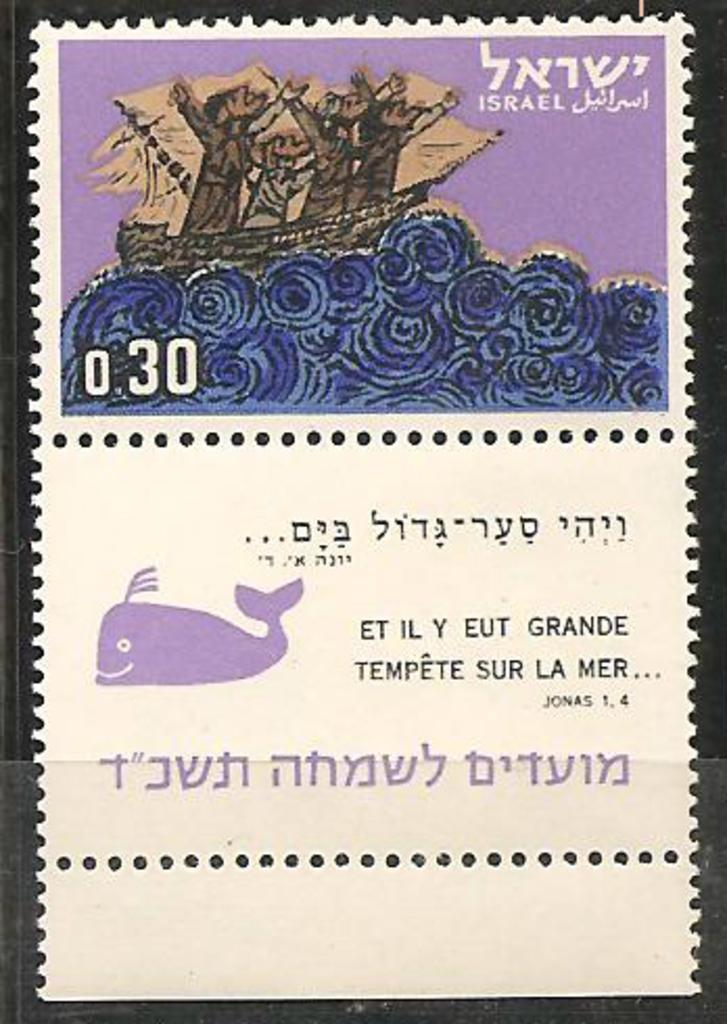What is the main subject in the image? There is a poster in the image. What type of gun is depicted in the poster? There is no gun present in the image; it only features a poster. What is the income of the person who created the poster? The income of the person who created the poster is not mentioned in the image, nor is it relevant to the image's content. 